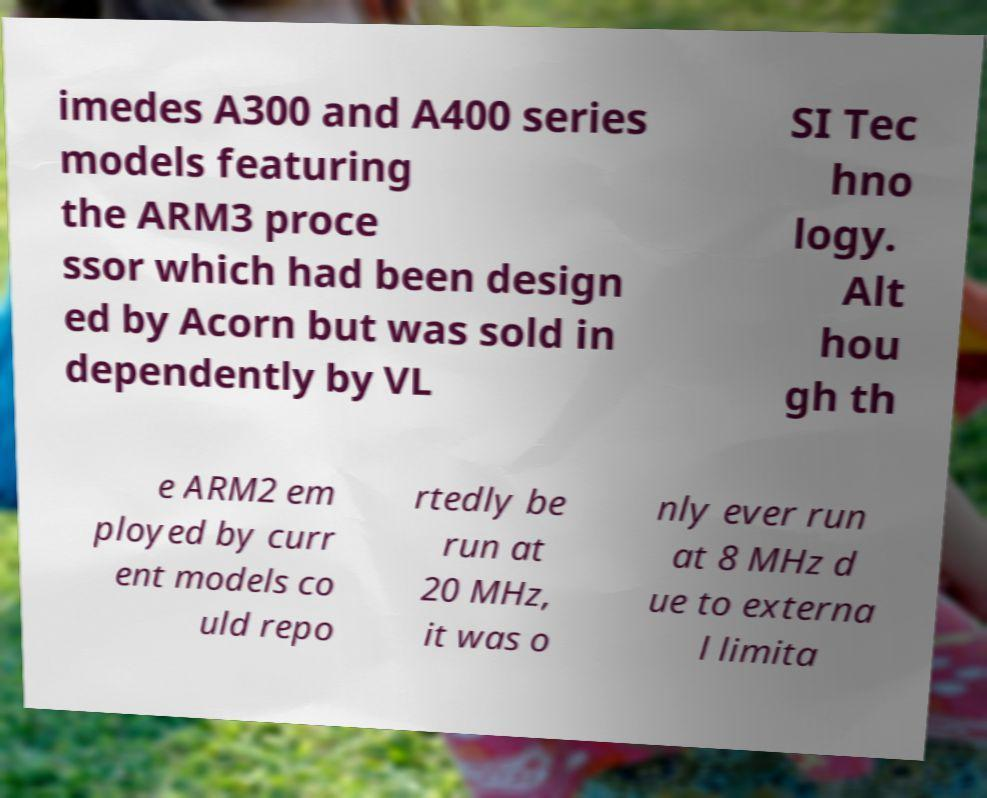Could you extract and type out the text from this image? imedes A300 and A400 series models featuring the ARM3 proce ssor which had been design ed by Acorn but was sold in dependently by VL SI Tec hno logy. Alt hou gh th e ARM2 em ployed by curr ent models co uld repo rtedly be run at 20 MHz, it was o nly ever run at 8 MHz d ue to externa l limita 